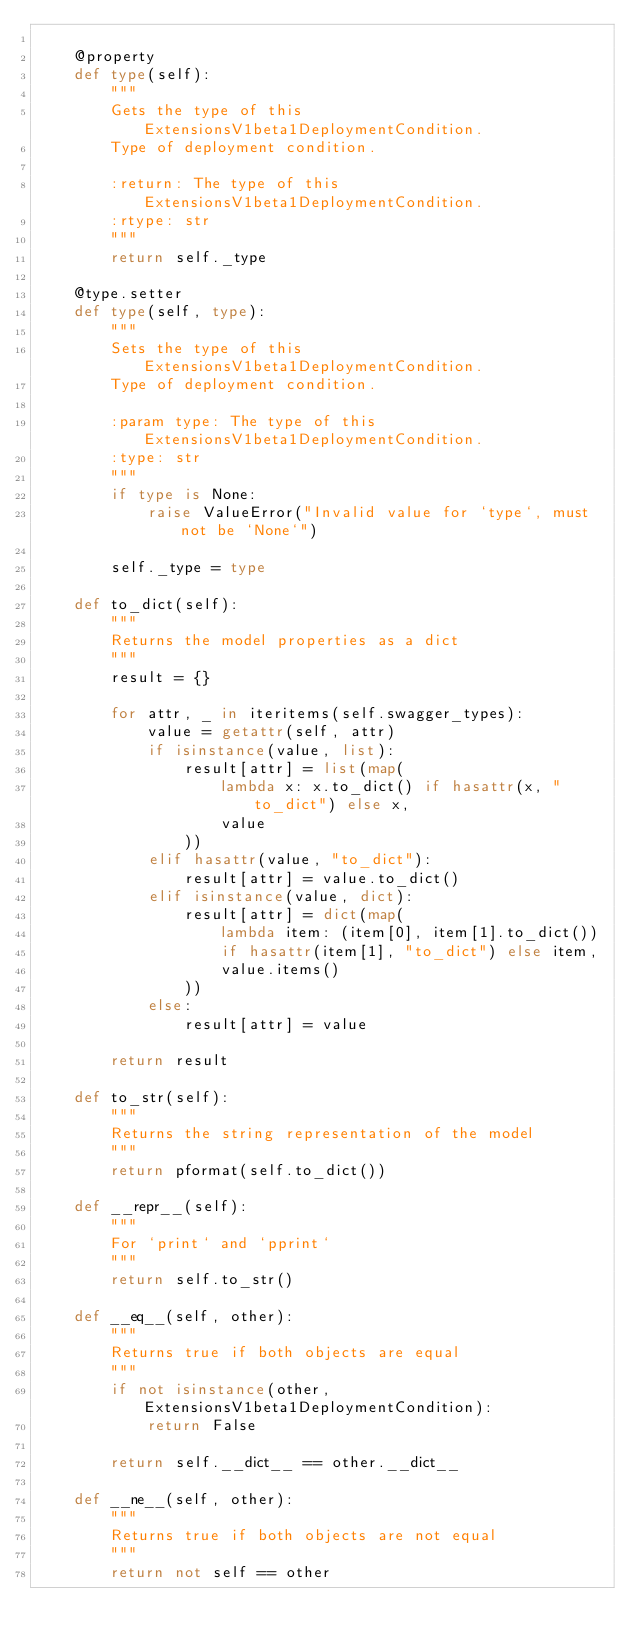<code> <loc_0><loc_0><loc_500><loc_500><_Python_>
    @property
    def type(self):
        """
        Gets the type of this ExtensionsV1beta1DeploymentCondition.
        Type of deployment condition.

        :return: The type of this ExtensionsV1beta1DeploymentCondition.
        :rtype: str
        """
        return self._type

    @type.setter
    def type(self, type):
        """
        Sets the type of this ExtensionsV1beta1DeploymentCondition.
        Type of deployment condition.

        :param type: The type of this ExtensionsV1beta1DeploymentCondition.
        :type: str
        """
        if type is None:
            raise ValueError("Invalid value for `type`, must not be `None`")

        self._type = type

    def to_dict(self):
        """
        Returns the model properties as a dict
        """
        result = {}

        for attr, _ in iteritems(self.swagger_types):
            value = getattr(self, attr)
            if isinstance(value, list):
                result[attr] = list(map(
                    lambda x: x.to_dict() if hasattr(x, "to_dict") else x,
                    value
                ))
            elif hasattr(value, "to_dict"):
                result[attr] = value.to_dict()
            elif isinstance(value, dict):
                result[attr] = dict(map(
                    lambda item: (item[0], item[1].to_dict())
                    if hasattr(item[1], "to_dict") else item,
                    value.items()
                ))
            else:
                result[attr] = value

        return result

    def to_str(self):
        """
        Returns the string representation of the model
        """
        return pformat(self.to_dict())

    def __repr__(self):
        """
        For `print` and `pprint`
        """
        return self.to_str()

    def __eq__(self, other):
        """
        Returns true if both objects are equal
        """
        if not isinstance(other, ExtensionsV1beta1DeploymentCondition):
            return False

        return self.__dict__ == other.__dict__

    def __ne__(self, other):
        """
        Returns true if both objects are not equal
        """
        return not self == other
</code> 